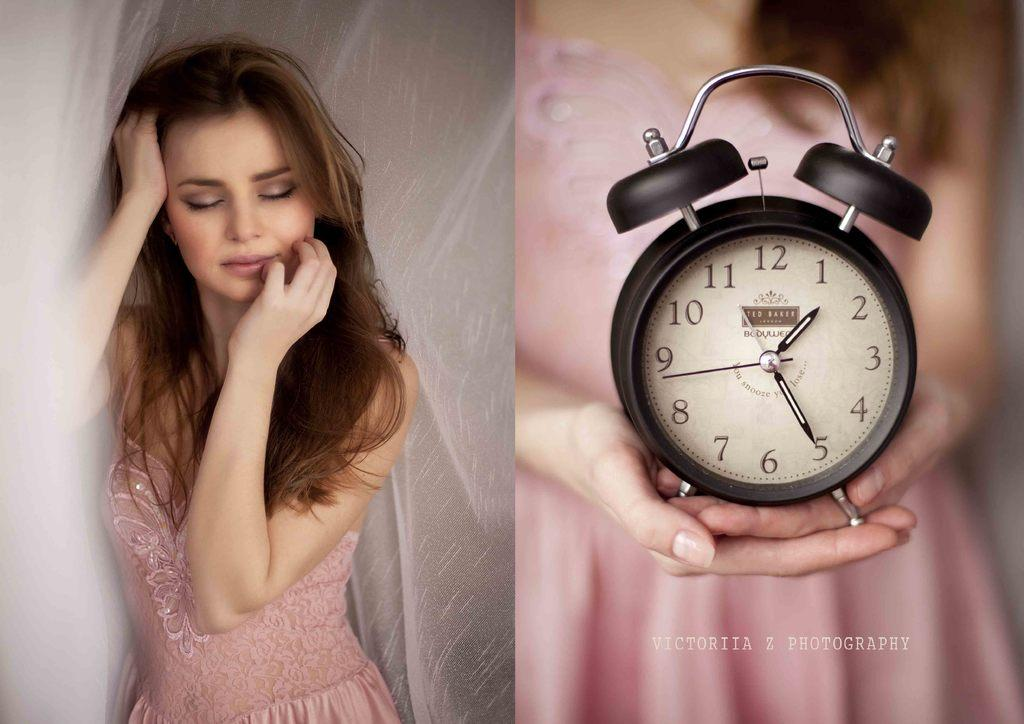<image>
Create a compact narrative representing the image presented. A woman is sleeping on the left side and on the right she is holding a clock showing a time of 1:25. 